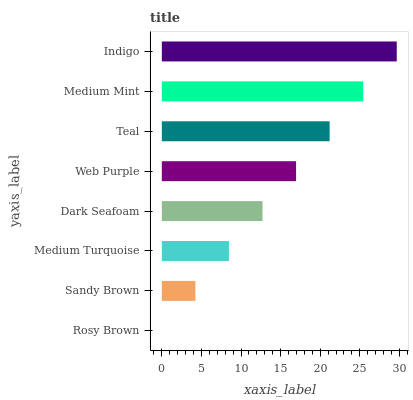Is Rosy Brown the minimum?
Answer yes or no. Yes. Is Indigo the maximum?
Answer yes or no. Yes. Is Sandy Brown the minimum?
Answer yes or no. No. Is Sandy Brown the maximum?
Answer yes or no. No. Is Sandy Brown greater than Rosy Brown?
Answer yes or no. Yes. Is Rosy Brown less than Sandy Brown?
Answer yes or no. Yes. Is Rosy Brown greater than Sandy Brown?
Answer yes or no. No. Is Sandy Brown less than Rosy Brown?
Answer yes or no. No. Is Web Purple the high median?
Answer yes or no. Yes. Is Dark Seafoam the low median?
Answer yes or no. Yes. Is Medium Mint the high median?
Answer yes or no. No. Is Web Purple the low median?
Answer yes or no. No. 